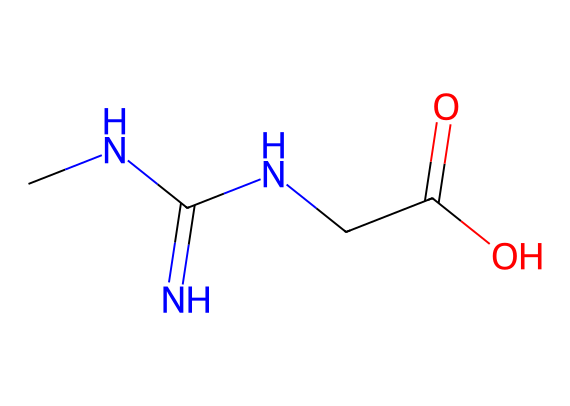What is the molecular formula of this compound? The SMILES representation indicates the number of each type of atom present. In the formula CNC(=N)NCC(=O)O, there are 4 carbon (C), 8 hydrogen (H), 5 nitrogen (N), and 2 oxygen (O) atoms, leading to the molecular formula C4H10N4O2.
Answer: C4H10N4O2 How many nitrogen atoms are in this molecule? By examining the SMILES notation, we can identify the individual atoms present. There are four occurrences of the nitrogen (N) atom in the structure.
Answer: 4 What functional groups are present in this structure? Analyzing the structure from the SMILES representation reveals that it contains an amine group (indicated by the nitrogen atoms) and a carboxylic acid group (characterized by the C(=O)O part). Thus, both functional groups are found within this molecule.
Answer: amine and carboxylic acid Does this molecule have a double bond? The presence of "=" in the SMILES indicates a double bond between the carbon and nitrogen (C(=N)) and between the carbon and oxygen (C(=O)). Therefore, this chemical structure does indeed contain double bonds.
Answer: yes What type of drug is this compound classified as? The compound primarily serves as a nutritional supplement known for enhancing athletic performance and muscle mass. It fits the classification of a dietary supplement based on its common usage in fitness.
Answer: dietary supplement What is the primary role of this compound in the body? This compound, commonly found in creatine supplements, plays a key role in energy production, particularly in the form of ATP (adenosine triphosphate) synthesis during high-intensity exercise.
Answer: energy production How many total atoms are in this molecular structure? From the molecular formula, which is C4H10N4O2, we can count the total atoms: 4 (carbon) + 10 (hydrogen) + 4 (nitrogen) + 2 (oxygen) equals 20 total atoms.
Answer: 20 